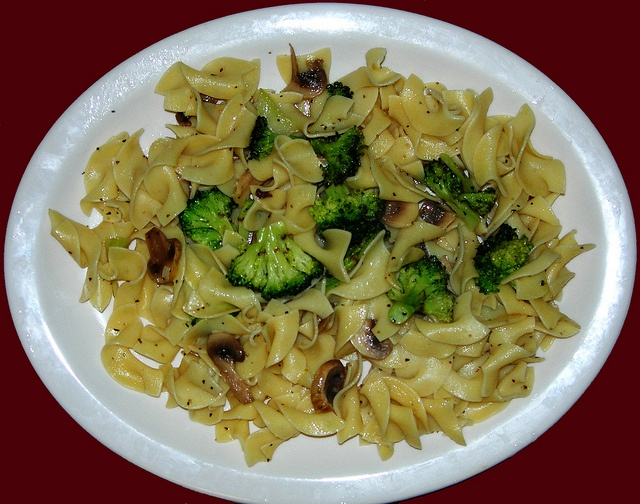Describe the objects in this image and their specific colors. I can see dining table in maroon, olive, and darkgray tones, broccoli in maroon, olive, black, and darkgreen tones, broccoli in maroon, darkgreen, black, and olive tones, broccoli in maroon, darkgreen, black, and green tones, and broccoli in maroon, black, darkgreen, and olive tones in this image. 